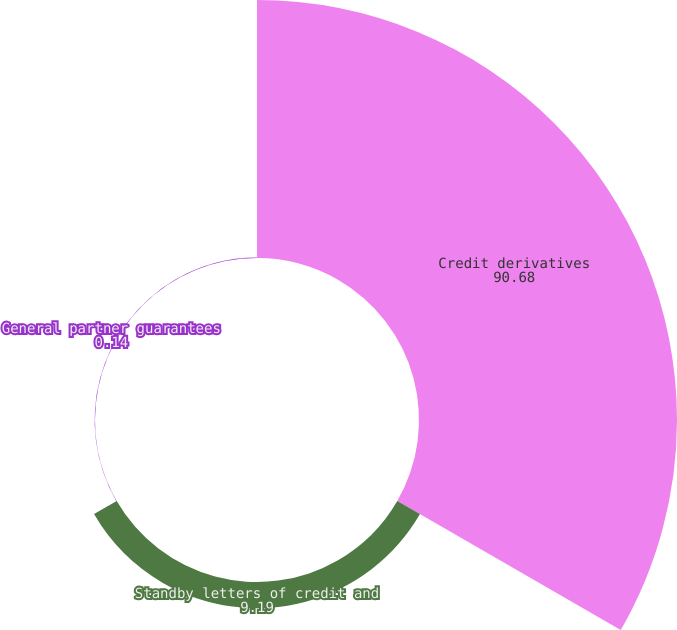Convert chart to OTSL. <chart><loc_0><loc_0><loc_500><loc_500><pie_chart><fcel>Credit derivatives<fcel>Standby letters of credit and<fcel>General partner guarantees<nl><fcel>90.68%<fcel>9.19%<fcel>0.14%<nl></chart> 